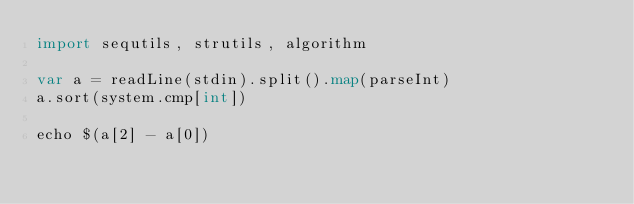<code> <loc_0><loc_0><loc_500><loc_500><_Nim_>import sequtils, strutils, algorithm

var a = readLine(stdin).split().map(parseInt)
a.sort(system.cmp[int])

echo $(a[2] - a[0])
</code> 